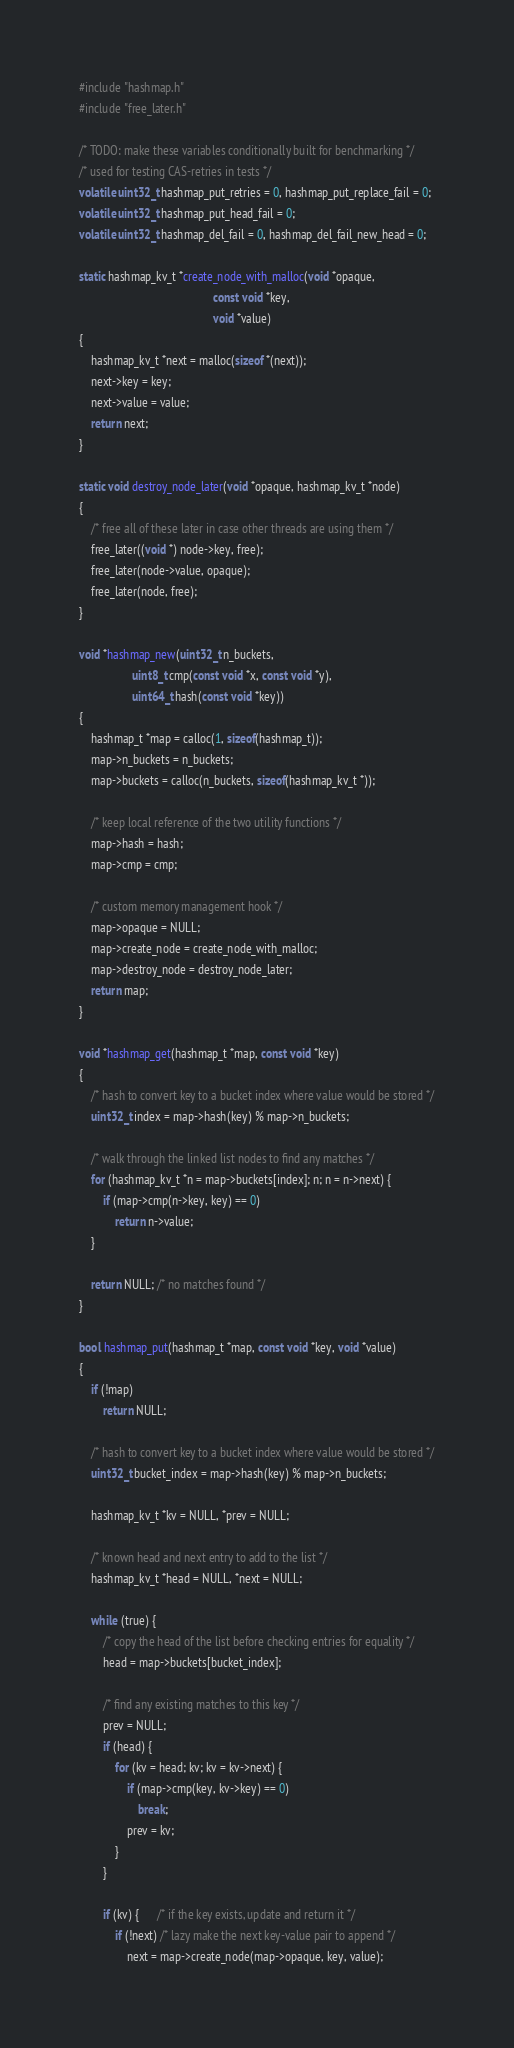Convert code to text. <code><loc_0><loc_0><loc_500><loc_500><_C_>#include "hashmap.h"
#include "free_later.h"

/* TODO: make these variables conditionally built for benchmarking */
/* used for testing CAS-retries in tests */
volatile uint32_t hashmap_put_retries = 0, hashmap_put_replace_fail = 0;
volatile uint32_t hashmap_put_head_fail = 0;
volatile uint32_t hashmap_del_fail = 0, hashmap_del_fail_new_head = 0;

static hashmap_kv_t *create_node_with_malloc(void *opaque,
                                             const void *key,
                                             void *value)
{
    hashmap_kv_t *next = malloc(sizeof *(next));
    next->key = key;
    next->value = value;
    return next;
}

static void destroy_node_later(void *opaque, hashmap_kv_t *node)
{
    /* free all of these later in case other threads are using them */
    free_later((void *) node->key, free);
    free_later(node->value, opaque);
    free_later(node, free);
}

void *hashmap_new(uint32_t n_buckets,
                  uint8_t cmp(const void *x, const void *y),
                  uint64_t hash(const void *key))
{
    hashmap_t *map = calloc(1, sizeof(hashmap_t));
    map->n_buckets = n_buckets;
    map->buckets = calloc(n_buckets, sizeof(hashmap_kv_t *));

    /* keep local reference of the two utility functions */
    map->hash = hash;
    map->cmp = cmp;

    /* custom memory management hook */
    map->opaque = NULL;
    map->create_node = create_node_with_malloc;
    map->destroy_node = destroy_node_later;
    return map;
}

void *hashmap_get(hashmap_t *map, const void *key)
{
    /* hash to convert key to a bucket index where value would be stored */
    uint32_t index = map->hash(key) % map->n_buckets;

    /* walk through the linked list nodes to find any matches */
    for (hashmap_kv_t *n = map->buckets[index]; n; n = n->next) {
        if (map->cmp(n->key, key) == 0)
            return n->value;
    }

    return NULL; /* no matches found */
}

bool hashmap_put(hashmap_t *map, const void *key, void *value)
{
    if (!map)
        return NULL;

    /* hash to convert key to a bucket index where value would be stored */
    uint32_t bucket_index = map->hash(key) % map->n_buckets;

    hashmap_kv_t *kv = NULL, *prev = NULL;

    /* known head and next entry to add to the list */
    hashmap_kv_t *head = NULL, *next = NULL;

    while (true) {
        /* copy the head of the list before checking entries for equality */
        head = map->buckets[bucket_index];

        /* find any existing matches to this key */
        prev = NULL;
        if (head) {
            for (kv = head; kv; kv = kv->next) {
                if (map->cmp(key, kv->key) == 0)
                    break;
                prev = kv;
            }
        }

        if (kv) {      /* if the key exists, update and return it */
            if (!next) /* lazy make the next key-value pair to append */
                next = map->create_node(map->opaque, key, value);
</code> 